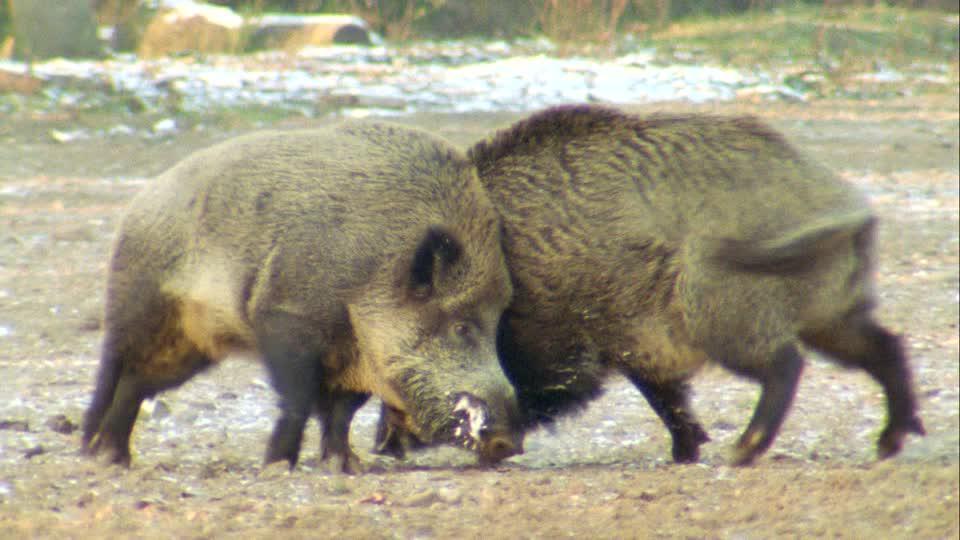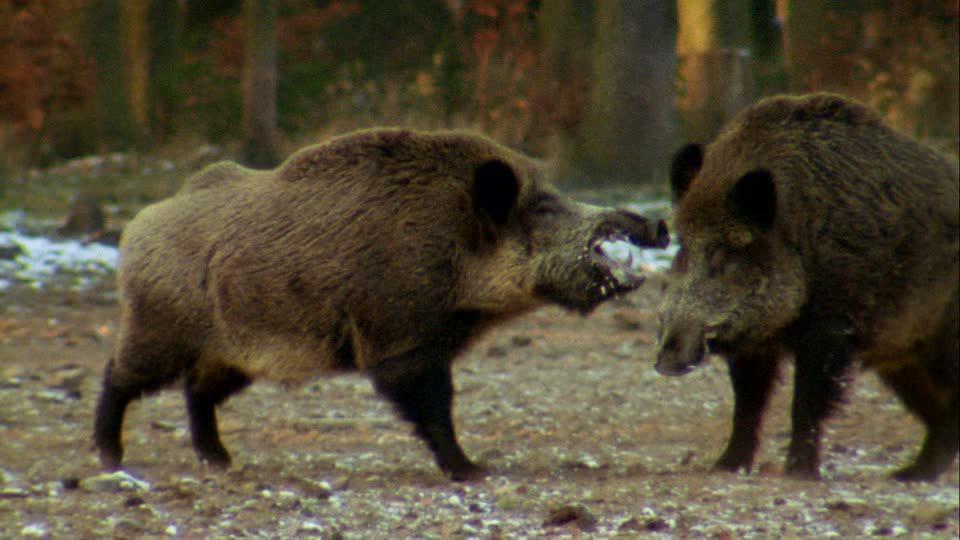The first image is the image on the left, the second image is the image on the right. Examine the images to the left and right. Is the description "There is a single animal in the right image." accurate? Answer yes or no. No. The first image is the image on the left, the second image is the image on the right. Examine the images to the left and right. Is the description "Each image includes a pair of animals facing-off aggressively, and the right image features a boar with its mouth open baring fangs." accurate? Answer yes or no. Yes. 